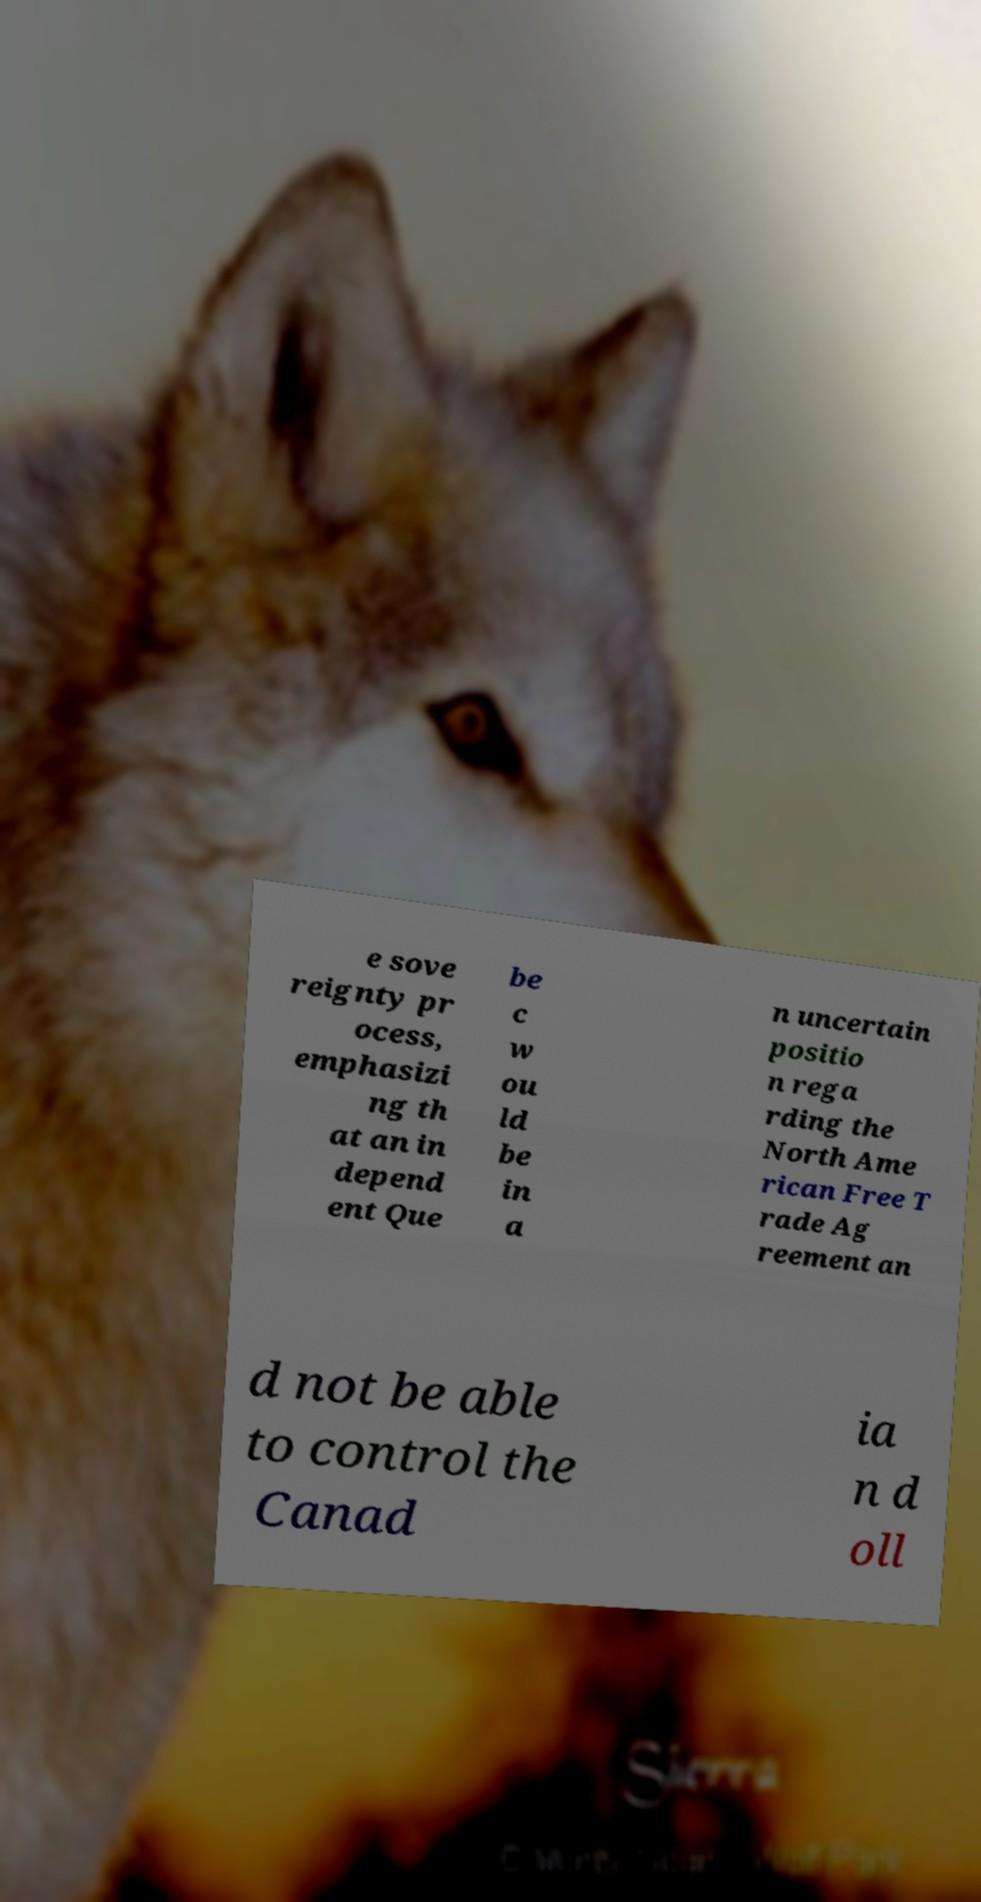Could you extract and type out the text from this image? e sove reignty pr ocess, emphasizi ng th at an in depend ent Que be c w ou ld be in a n uncertain positio n rega rding the North Ame rican Free T rade Ag reement an d not be able to control the Canad ia n d oll 